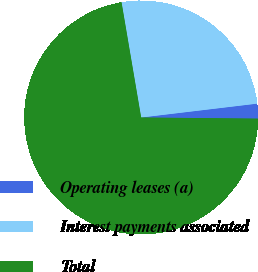<chart> <loc_0><loc_0><loc_500><loc_500><pie_chart><fcel>Operating leases (a)<fcel>Interest payments associated<fcel>Total<nl><fcel>2.05%<fcel>25.79%<fcel>72.16%<nl></chart> 